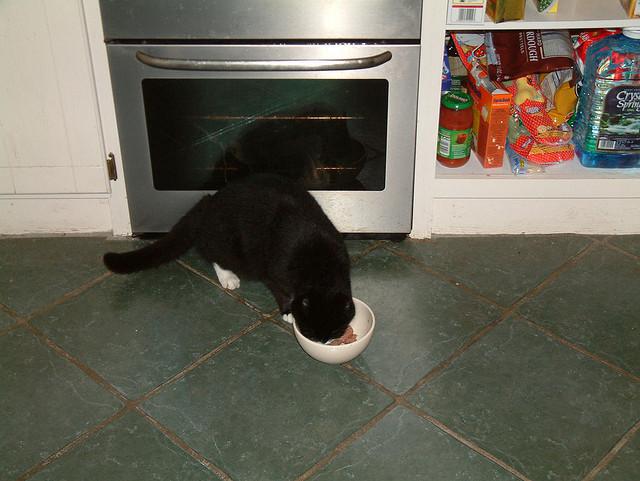What color is the tile?
Be succinct. Green. What is lying in front of the oven?
Answer briefly. Cat. What is the cat doing?
Write a very short answer. Eating. What appliance is the cat sitting in front of?
Quick response, please. Oven. 